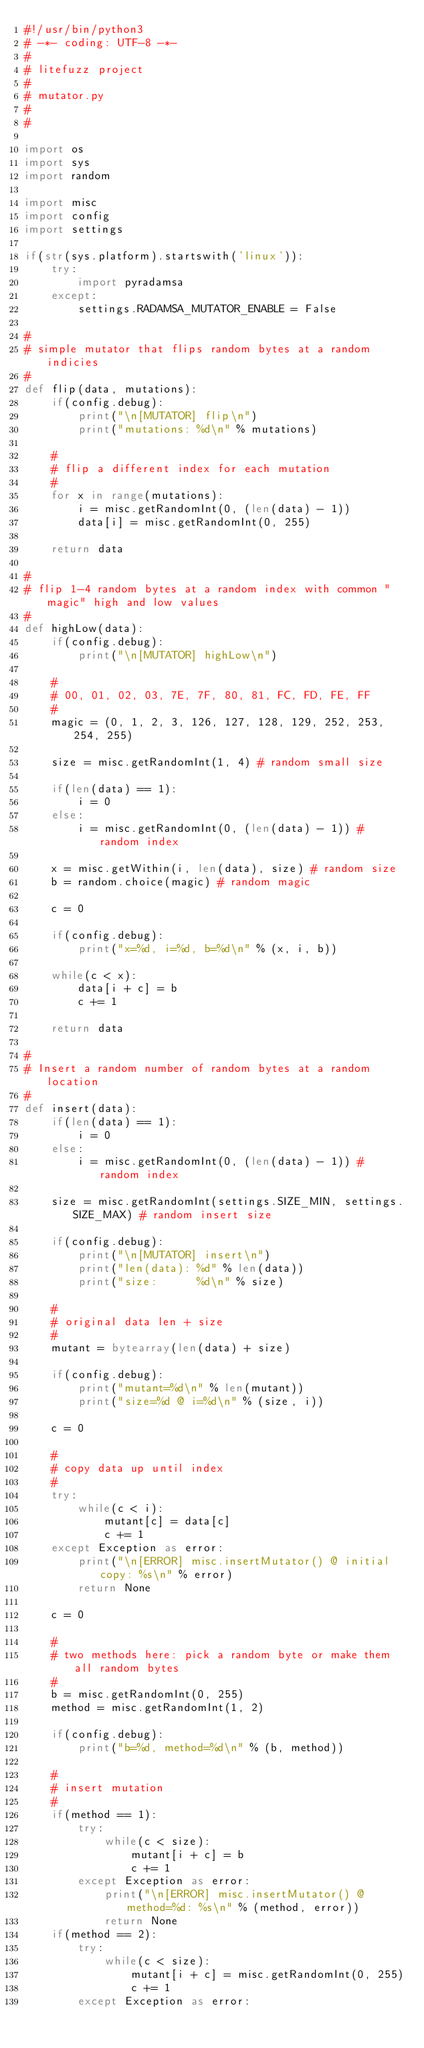<code> <loc_0><loc_0><loc_500><loc_500><_Python_>#!/usr/bin/python3
# -*- coding: UTF-8 -*-
#
# litefuzz project
#
# mutator.py
#
#

import os
import sys
import random

import misc
import config
import settings

if(str(sys.platform).startswith('linux')):
    try:
        import pyradamsa
    except:
        settings.RADAMSA_MUTATOR_ENABLE = False

#
# simple mutator that flips random bytes at a random indicies
#
def flip(data, mutations):
    if(config.debug):
        print("\n[MUTATOR] flip\n")
        print("mutations: %d\n" % mutations)

    #
    # flip a different index for each mutation
    #
    for x in range(mutations):
        i = misc.getRandomInt(0, (len(data) - 1))
        data[i] = misc.getRandomInt(0, 255)

    return data

#
# flip 1-4 random bytes at a random index with common "magic" high and low values
#
def highLow(data):
    if(config.debug):
        print("\n[MUTATOR] highLow\n")

    #
    # 00, 01, 02, 03, 7E, 7F, 80, 81, FC, FD, FE, FF
    #
    magic = (0, 1, 2, 3, 126, 127, 128, 129, 252, 253, 254, 255)

    size = misc.getRandomInt(1, 4) # random small size

    if(len(data) == 1):
        i = 0
    else:
        i = misc.getRandomInt(0, (len(data) - 1)) # random index

    x = misc.getWithin(i, len(data), size) # random size
    b = random.choice(magic) # random magic

    c = 0

    if(config.debug):
        print("x=%d, i=%d, b=%d\n" % (x, i, b))

    while(c < x):
        data[i + c] = b
        c += 1

    return data

#
# Insert a random number of random bytes at a random location
#
def insert(data):
    if(len(data) == 1):
        i = 0
    else:
        i = misc.getRandomInt(0, (len(data) - 1)) # random index

    size = misc.getRandomInt(settings.SIZE_MIN, settings.SIZE_MAX) # random insert size

    if(config.debug):
        print("\n[MUTATOR] insert\n")
        print("len(data): %d" % len(data))
        print("size:      %d\n" % size)

    #
    # original data len + size
    #
    mutant = bytearray(len(data) + size)

    if(config.debug):
        print("mutant=%d\n" % len(mutant))
        print("size=%d @ i=%d\n" % (size, i))

    c = 0

    #
    # copy data up until index
    #
    try:
        while(c < i):
            mutant[c] = data[c]
            c += 1
    except Exception as error:
        print("\n[ERROR] misc.insertMutator() @ initial copy: %s\n" % error)
        return None

    c = 0

    #
    # two methods here: pick a random byte or make them all random bytes
    #
    b = misc.getRandomInt(0, 255)
    method = misc.getRandomInt(1, 2)

    if(config.debug):
        print("b=%d, method=%d\n" % (b, method))

    #
    # insert mutation
    #
    if(method == 1):
        try:
            while(c < size):
                mutant[i + c] = b
                c += 1
        except Exception as error:
            print("\n[ERROR] misc.insertMutator() @ method=%d: %s\n" % (method, error))
            return None
    if(method == 2):
        try:
            while(c < size):
                mutant[i + c] = misc.getRandomInt(0, 255)
                c += 1
        except Exception as error:</code> 